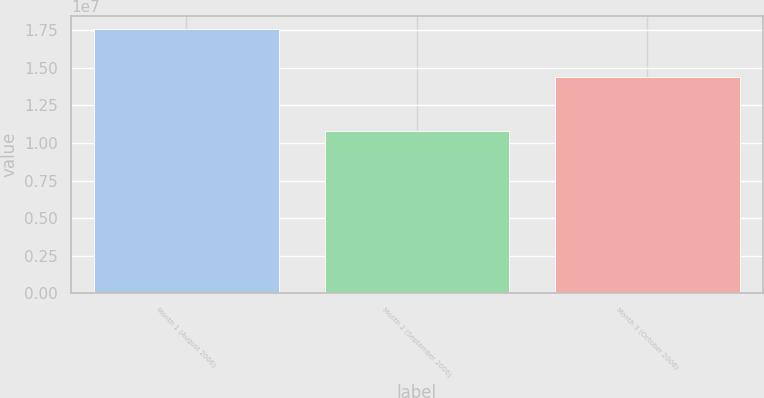<chart> <loc_0><loc_0><loc_500><loc_500><bar_chart><fcel>Month 1 (August 2006)<fcel>Month 2 (September 2006)<fcel>Month 3 (October 2006)<nl><fcel>1.75656e+07<fcel>1.07897e+07<fcel>1.43579e+07<nl></chart> 